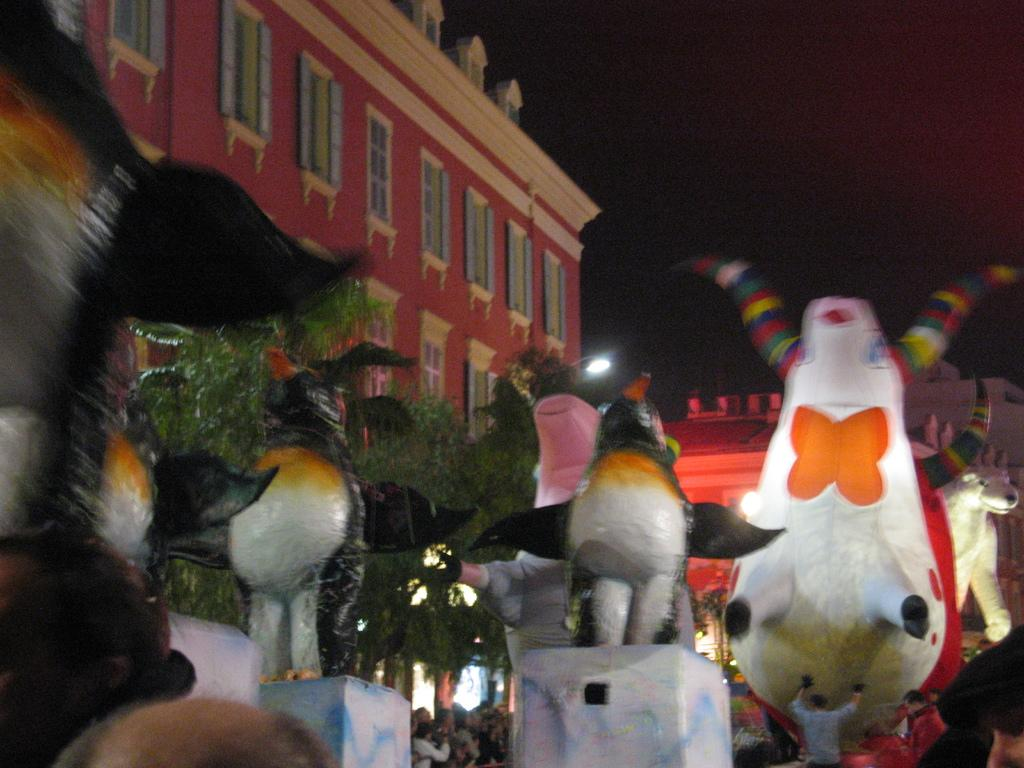What type of structures can be seen in the image? There are buildings in the image. Are there any living beings present in the image? Yes, there are people in the image. What else can be seen in the image besides buildings and people? There are objects in the image. What is the source of illumination in the image? There is light in the image. What can be seen in the distance in the image? The sky is visible in the background of the image. Can you describe the rhythm of the dinosaurs in the image? There are no dinosaurs present in the image, so there is no rhythm to describe. What type of flower is growing near the people in the image? There is no flower present in the image; it features buildings, people, and objects. 